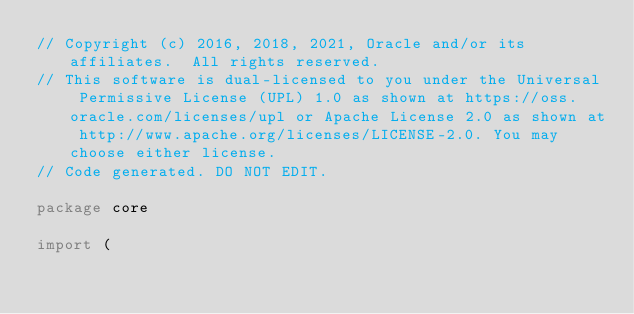<code> <loc_0><loc_0><loc_500><loc_500><_Go_>// Copyright (c) 2016, 2018, 2021, Oracle and/or its affiliates.  All rights reserved.
// This software is dual-licensed to you under the Universal Permissive License (UPL) 1.0 as shown at https://oss.oracle.com/licenses/upl or Apache License 2.0 as shown at http://www.apache.org/licenses/LICENSE-2.0. You may choose either license.
// Code generated. DO NOT EDIT.

package core

import (</code> 